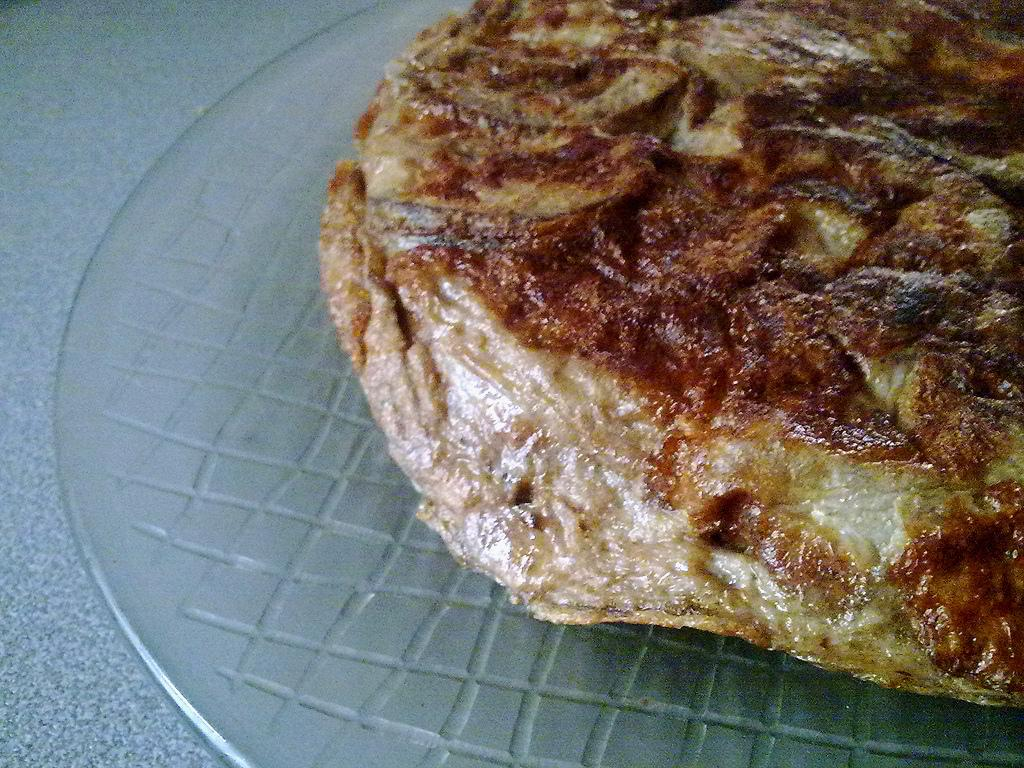What is the main subject of the image? There is a food item in the image. How is the food item positioned in the image? The food item is placed on a glass. What type of sign can be seen on the dock in the image? There is no dock or sign present in the image; it only features a food item placed on a glass. 